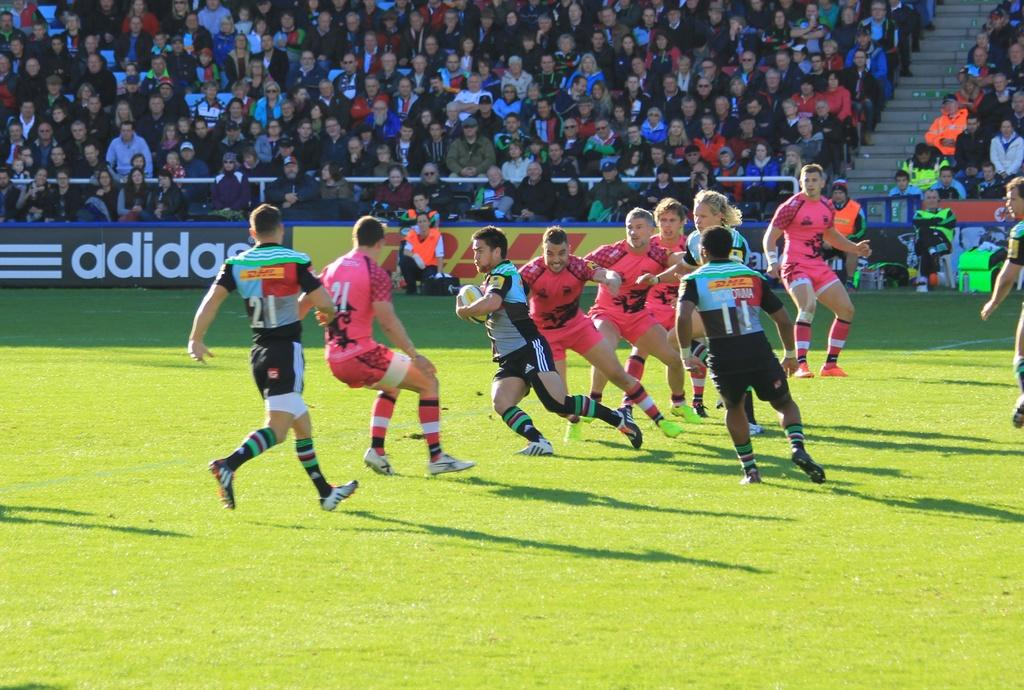<image>
Give a short and clear explanation of the subsequent image. A player in a multi color jersey with the number 21 goes after a player in a pink jersey also with the number 21 